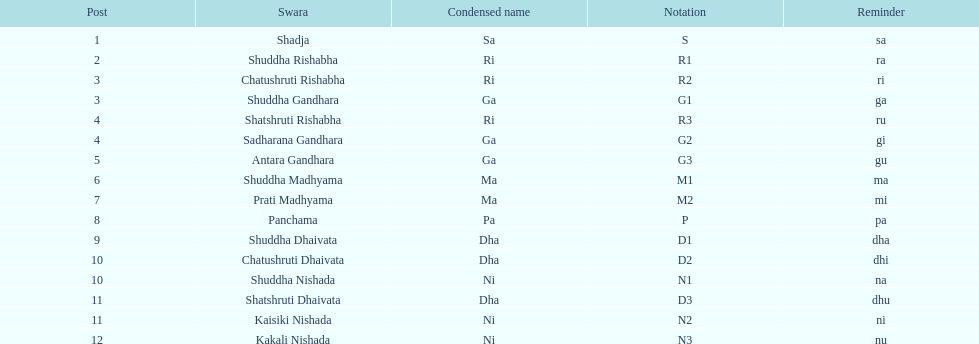Which swara follows immediately after antara gandhara? Shuddha Madhyama. 